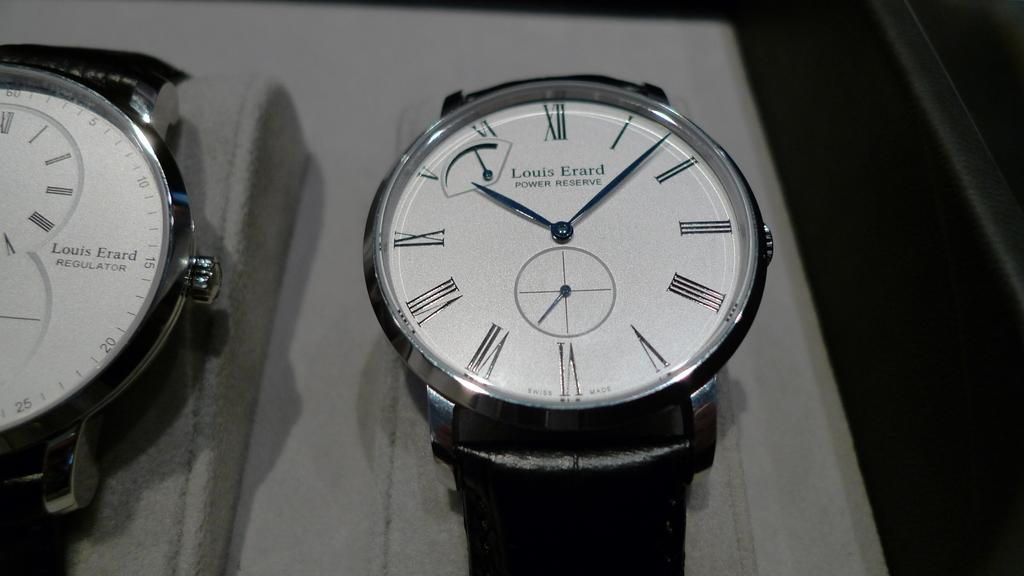<image>
Provide a brief description of the given image. White face of a watch which says Louis Erard on it. 